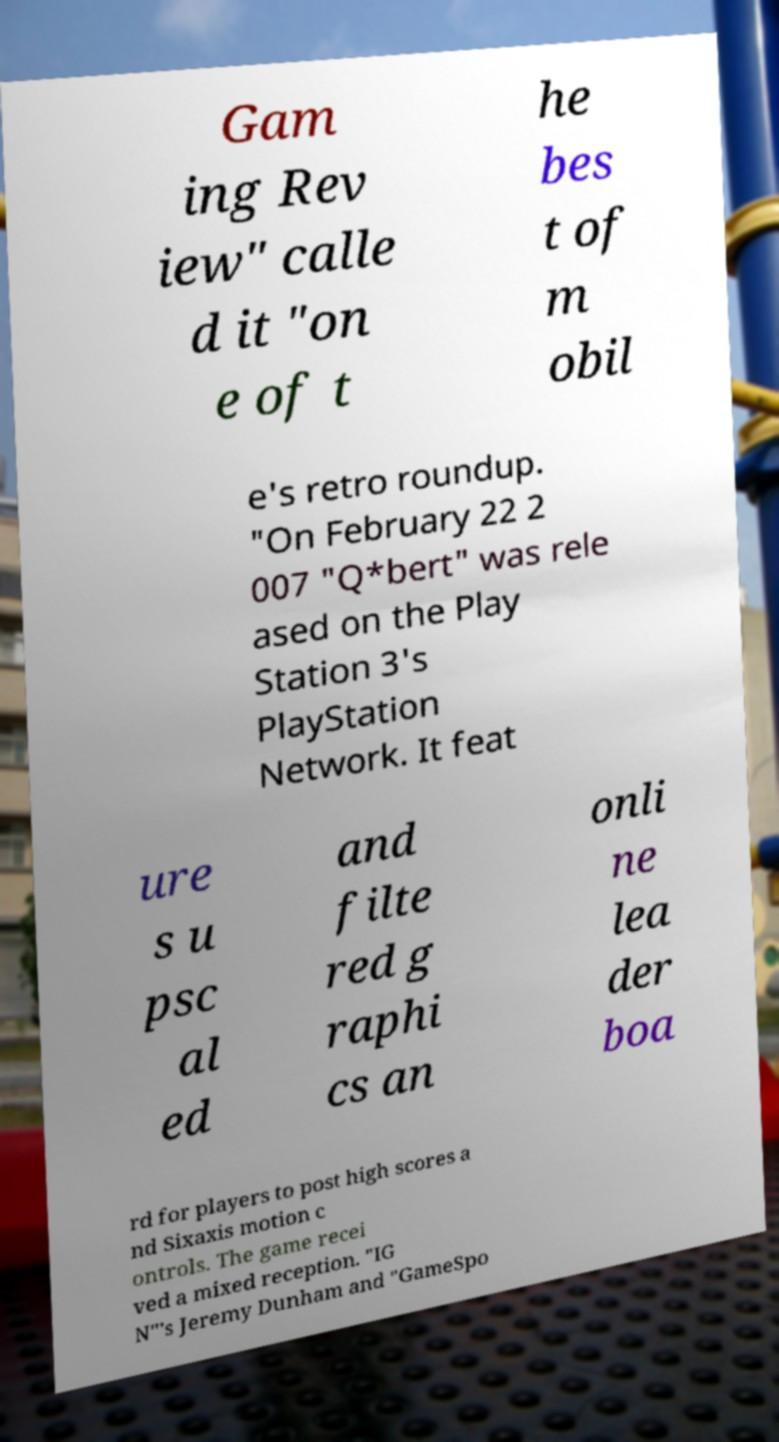Can you accurately transcribe the text from the provided image for me? Gam ing Rev iew" calle d it "on e of t he bes t of m obil e's retro roundup. "On February 22 2 007 "Q*bert" was rele ased on the Play Station 3's PlayStation Network. It feat ure s u psc al ed and filte red g raphi cs an onli ne lea der boa rd for players to post high scores a nd Sixaxis motion c ontrols. The game recei ved a mixed reception. "IG N"'s Jeremy Dunham and "GameSpo 